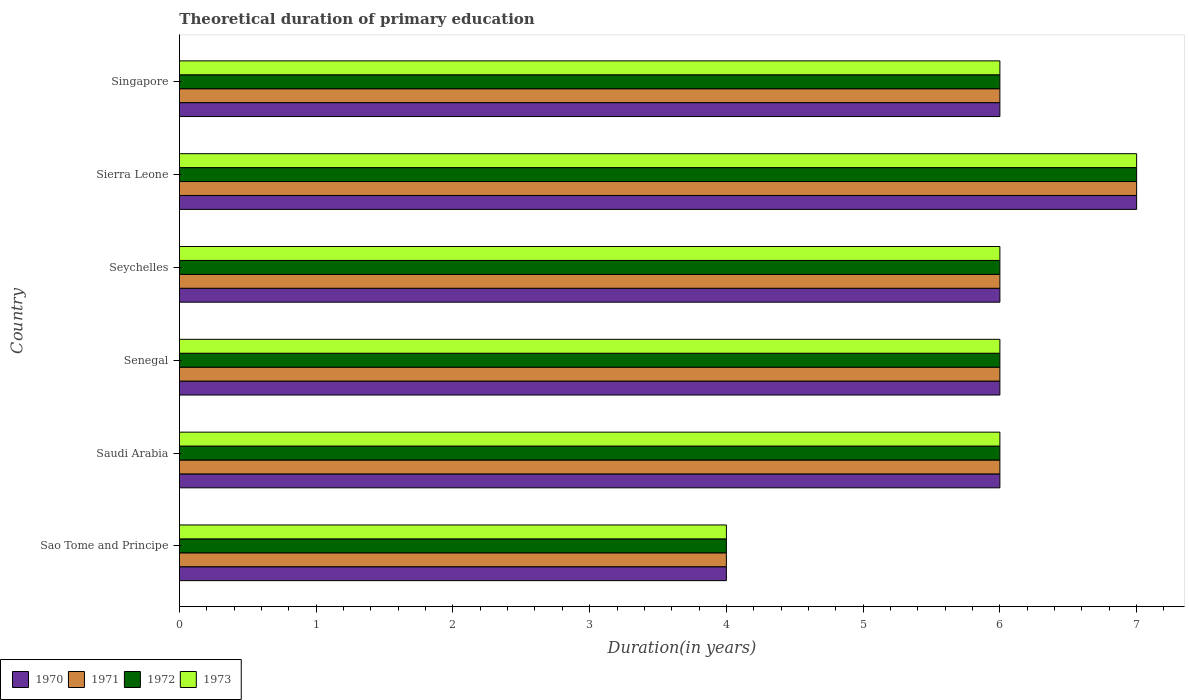How many groups of bars are there?
Offer a very short reply. 6. Are the number of bars per tick equal to the number of legend labels?
Your answer should be very brief. Yes. How many bars are there on the 4th tick from the top?
Ensure brevity in your answer.  4. What is the label of the 3rd group of bars from the top?
Your answer should be compact. Seychelles. In how many cases, is the number of bars for a given country not equal to the number of legend labels?
Your answer should be compact. 0. What is the total theoretical duration of primary education in 1970 in Saudi Arabia?
Ensure brevity in your answer.  6. In which country was the total theoretical duration of primary education in 1973 maximum?
Provide a succinct answer. Sierra Leone. In which country was the total theoretical duration of primary education in 1973 minimum?
Your answer should be very brief. Sao Tome and Principe. What is the total total theoretical duration of primary education in 1970 in the graph?
Offer a terse response. 35. What is the average total theoretical duration of primary education in 1973 per country?
Your response must be concise. 5.83. In how many countries, is the total theoretical duration of primary education in 1971 greater than 6.2 years?
Make the answer very short. 1. What is the ratio of the total theoretical duration of primary education in 1973 in Saudi Arabia to that in Senegal?
Give a very brief answer. 1. Is the total theoretical duration of primary education in 1972 in Saudi Arabia less than that in Senegal?
Make the answer very short. No. What is the difference between the highest and the second highest total theoretical duration of primary education in 1971?
Your answer should be compact. 1. In how many countries, is the total theoretical duration of primary education in 1973 greater than the average total theoretical duration of primary education in 1973 taken over all countries?
Offer a terse response. 5. Is the sum of the total theoretical duration of primary education in 1972 in Sierra Leone and Singapore greater than the maximum total theoretical duration of primary education in 1970 across all countries?
Your answer should be very brief. Yes. What does the 3rd bar from the top in Seychelles represents?
Ensure brevity in your answer.  1971. Is it the case that in every country, the sum of the total theoretical duration of primary education in 1973 and total theoretical duration of primary education in 1970 is greater than the total theoretical duration of primary education in 1971?
Offer a very short reply. Yes. Are all the bars in the graph horizontal?
Offer a terse response. Yes. Are the values on the major ticks of X-axis written in scientific E-notation?
Your answer should be compact. No. Does the graph contain any zero values?
Provide a succinct answer. No. Where does the legend appear in the graph?
Your response must be concise. Bottom left. How many legend labels are there?
Ensure brevity in your answer.  4. What is the title of the graph?
Your answer should be compact. Theoretical duration of primary education. Does "1969" appear as one of the legend labels in the graph?
Ensure brevity in your answer.  No. What is the label or title of the X-axis?
Make the answer very short. Duration(in years). What is the label or title of the Y-axis?
Give a very brief answer. Country. What is the Duration(in years) in 1970 in Sao Tome and Principe?
Your answer should be very brief. 4. What is the Duration(in years) of 1973 in Sao Tome and Principe?
Provide a succinct answer. 4. What is the Duration(in years) of 1971 in Saudi Arabia?
Keep it short and to the point. 6. What is the Duration(in years) of 1972 in Saudi Arabia?
Provide a succinct answer. 6. What is the Duration(in years) in 1973 in Saudi Arabia?
Your answer should be very brief. 6. What is the Duration(in years) in 1971 in Senegal?
Your answer should be compact. 6. What is the Duration(in years) of 1973 in Senegal?
Make the answer very short. 6. What is the Duration(in years) in 1970 in Sierra Leone?
Your response must be concise. 7. What is the Duration(in years) of 1971 in Sierra Leone?
Your answer should be very brief. 7. What is the Duration(in years) in 1972 in Sierra Leone?
Provide a short and direct response. 7. What is the Duration(in years) in 1970 in Singapore?
Your answer should be very brief. 6. What is the Duration(in years) of 1971 in Singapore?
Give a very brief answer. 6. What is the Duration(in years) of 1972 in Singapore?
Your answer should be compact. 6. Across all countries, what is the maximum Duration(in years) in 1971?
Ensure brevity in your answer.  7. Across all countries, what is the minimum Duration(in years) of 1970?
Your answer should be compact. 4. Across all countries, what is the minimum Duration(in years) in 1972?
Make the answer very short. 4. Across all countries, what is the minimum Duration(in years) of 1973?
Your answer should be compact. 4. What is the total Duration(in years) in 1972 in the graph?
Provide a short and direct response. 35. What is the total Duration(in years) in 1973 in the graph?
Your answer should be very brief. 35. What is the difference between the Duration(in years) in 1970 in Sao Tome and Principe and that in Saudi Arabia?
Provide a succinct answer. -2. What is the difference between the Duration(in years) in 1971 in Sao Tome and Principe and that in Saudi Arabia?
Ensure brevity in your answer.  -2. What is the difference between the Duration(in years) in 1972 in Sao Tome and Principe and that in Saudi Arabia?
Keep it short and to the point. -2. What is the difference between the Duration(in years) in 1973 in Sao Tome and Principe and that in Saudi Arabia?
Provide a short and direct response. -2. What is the difference between the Duration(in years) of 1971 in Sao Tome and Principe and that in Senegal?
Provide a succinct answer. -2. What is the difference between the Duration(in years) in 1972 in Sao Tome and Principe and that in Senegal?
Provide a short and direct response. -2. What is the difference between the Duration(in years) of 1973 in Sao Tome and Principe and that in Senegal?
Your answer should be compact. -2. What is the difference between the Duration(in years) in 1973 in Sao Tome and Principe and that in Seychelles?
Give a very brief answer. -2. What is the difference between the Duration(in years) of 1970 in Sao Tome and Principe and that in Sierra Leone?
Make the answer very short. -3. What is the difference between the Duration(in years) in 1972 in Sao Tome and Principe and that in Sierra Leone?
Ensure brevity in your answer.  -3. What is the difference between the Duration(in years) of 1973 in Sao Tome and Principe and that in Sierra Leone?
Ensure brevity in your answer.  -3. What is the difference between the Duration(in years) in 1972 in Sao Tome and Principe and that in Singapore?
Your answer should be very brief. -2. What is the difference between the Duration(in years) of 1973 in Sao Tome and Principe and that in Singapore?
Offer a terse response. -2. What is the difference between the Duration(in years) in 1971 in Saudi Arabia and that in Senegal?
Your answer should be compact. 0. What is the difference between the Duration(in years) in 1973 in Saudi Arabia and that in Senegal?
Your answer should be very brief. 0. What is the difference between the Duration(in years) in 1970 in Saudi Arabia and that in Seychelles?
Offer a very short reply. 0. What is the difference between the Duration(in years) of 1970 in Saudi Arabia and that in Sierra Leone?
Keep it short and to the point. -1. What is the difference between the Duration(in years) in 1971 in Saudi Arabia and that in Sierra Leone?
Offer a very short reply. -1. What is the difference between the Duration(in years) in 1973 in Saudi Arabia and that in Sierra Leone?
Provide a succinct answer. -1. What is the difference between the Duration(in years) of 1973 in Saudi Arabia and that in Singapore?
Your response must be concise. 0. What is the difference between the Duration(in years) in 1970 in Senegal and that in Seychelles?
Make the answer very short. 0. What is the difference between the Duration(in years) of 1971 in Senegal and that in Sierra Leone?
Your response must be concise. -1. What is the difference between the Duration(in years) in 1972 in Senegal and that in Sierra Leone?
Your response must be concise. -1. What is the difference between the Duration(in years) in 1972 in Seychelles and that in Sierra Leone?
Your response must be concise. -1. What is the difference between the Duration(in years) of 1970 in Seychelles and that in Singapore?
Your answer should be compact. 0. What is the difference between the Duration(in years) in 1971 in Seychelles and that in Singapore?
Give a very brief answer. 0. What is the difference between the Duration(in years) in 1970 in Sao Tome and Principe and the Duration(in years) in 1971 in Saudi Arabia?
Ensure brevity in your answer.  -2. What is the difference between the Duration(in years) in 1970 in Sao Tome and Principe and the Duration(in years) in 1972 in Saudi Arabia?
Offer a terse response. -2. What is the difference between the Duration(in years) in 1970 in Sao Tome and Principe and the Duration(in years) in 1973 in Saudi Arabia?
Your answer should be compact. -2. What is the difference between the Duration(in years) of 1971 in Sao Tome and Principe and the Duration(in years) of 1972 in Saudi Arabia?
Give a very brief answer. -2. What is the difference between the Duration(in years) of 1970 in Sao Tome and Principe and the Duration(in years) of 1971 in Senegal?
Keep it short and to the point. -2. What is the difference between the Duration(in years) of 1970 in Sao Tome and Principe and the Duration(in years) of 1972 in Senegal?
Offer a terse response. -2. What is the difference between the Duration(in years) of 1972 in Sao Tome and Principe and the Duration(in years) of 1973 in Senegal?
Give a very brief answer. -2. What is the difference between the Duration(in years) in 1970 in Sao Tome and Principe and the Duration(in years) in 1972 in Seychelles?
Provide a succinct answer. -2. What is the difference between the Duration(in years) of 1970 in Sao Tome and Principe and the Duration(in years) of 1973 in Seychelles?
Keep it short and to the point. -2. What is the difference between the Duration(in years) of 1971 in Sao Tome and Principe and the Duration(in years) of 1973 in Seychelles?
Give a very brief answer. -2. What is the difference between the Duration(in years) of 1972 in Sao Tome and Principe and the Duration(in years) of 1973 in Seychelles?
Your response must be concise. -2. What is the difference between the Duration(in years) in 1970 in Sao Tome and Principe and the Duration(in years) in 1973 in Sierra Leone?
Your answer should be compact. -3. What is the difference between the Duration(in years) of 1971 in Sao Tome and Principe and the Duration(in years) of 1973 in Sierra Leone?
Keep it short and to the point. -3. What is the difference between the Duration(in years) in 1972 in Sao Tome and Principe and the Duration(in years) in 1973 in Sierra Leone?
Your answer should be compact. -3. What is the difference between the Duration(in years) of 1970 in Sao Tome and Principe and the Duration(in years) of 1973 in Singapore?
Offer a very short reply. -2. What is the difference between the Duration(in years) of 1971 in Sao Tome and Principe and the Duration(in years) of 1972 in Singapore?
Your answer should be compact. -2. What is the difference between the Duration(in years) of 1970 in Saudi Arabia and the Duration(in years) of 1972 in Senegal?
Provide a succinct answer. 0. What is the difference between the Duration(in years) in 1970 in Saudi Arabia and the Duration(in years) in 1973 in Senegal?
Provide a succinct answer. 0. What is the difference between the Duration(in years) in 1970 in Saudi Arabia and the Duration(in years) in 1972 in Seychelles?
Ensure brevity in your answer.  0. What is the difference between the Duration(in years) of 1971 in Saudi Arabia and the Duration(in years) of 1973 in Seychelles?
Your answer should be very brief. 0. What is the difference between the Duration(in years) in 1971 in Saudi Arabia and the Duration(in years) in 1972 in Sierra Leone?
Your answer should be very brief. -1. What is the difference between the Duration(in years) of 1971 in Saudi Arabia and the Duration(in years) of 1973 in Sierra Leone?
Offer a terse response. -1. What is the difference between the Duration(in years) in 1972 in Saudi Arabia and the Duration(in years) in 1973 in Sierra Leone?
Your answer should be compact. -1. What is the difference between the Duration(in years) of 1970 in Saudi Arabia and the Duration(in years) of 1972 in Singapore?
Provide a succinct answer. 0. What is the difference between the Duration(in years) in 1970 in Saudi Arabia and the Duration(in years) in 1973 in Singapore?
Your response must be concise. 0. What is the difference between the Duration(in years) of 1971 in Saudi Arabia and the Duration(in years) of 1972 in Singapore?
Your answer should be compact. 0. What is the difference between the Duration(in years) of 1970 in Senegal and the Duration(in years) of 1972 in Seychelles?
Provide a short and direct response. 0. What is the difference between the Duration(in years) in 1971 in Senegal and the Duration(in years) in 1972 in Seychelles?
Offer a terse response. 0. What is the difference between the Duration(in years) in 1971 in Senegal and the Duration(in years) in 1973 in Seychelles?
Give a very brief answer. 0. What is the difference between the Duration(in years) of 1970 in Senegal and the Duration(in years) of 1972 in Sierra Leone?
Keep it short and to the point. -1. What is the difference between the Duration(in years) in 1971 in Senegal and the Duration(in years) in 1972 in Sierra Leone?
Give a very brief answer. -1. What is the difference between the Duration(in years) of 1971 in Senegal and the Duration(in years) of 1973 in Sierra Leone?
Offer a very short reply. -1. What is the difference between the Duration(in years) in 1970 in Senegal and the Duration(in years) in 1971 in Singapore?
Ensure brevity in your answer.  0. What is the difference between the Duration(in years) of 1972 in Senegal and the Duration(in years) of 1973 in Singapore?
Your answer should be compact. 0. What is the difference between the Duration(in years) of 1970 in Seychelles and the Duration(in years) of 1971 in Sierra Leone?
Ensure brevity in your answer.  -1. What is the difference between the Duration(in years) in 1971 in Seychelles and the Duration(in years) in 1972 in Sierra Leone?
Your answer should be compact. -1. What is the difference between the Duration(in years) in 1970 in Seychelles and the Duration(in years) in 1971 in Singapore?
Offer a very short reply. 0. What is the difference between the Duration(in years) of 1970 in Seychelles and the Duration(in years) of 1973 in Singapore?
Provide a succinct answer. 0. What is the difference between the Duration(in years) of 1971 in Seychelles and the Duration(in years) of 1972 in Singapore?
Ensure brevity in your answer.  0. What is the difference between the Duration(in years) of 1971 in Seychelles and the Duration(in years) of 1973 in Singapore?
Offer a terse response. 0. What is the difference between the Duration(in years) of 1972 in Seychelles and the Duration(in years) of 1973 in Singapore?
Offer a terse response. 0. What is the difference between the Duration(in years) of 1970 in Sierra Leone and the Duration(in years) of 1972 in Singapore?
Your answer should be compact. 1. What is the difference between the Duration(in years) in 1972 in Sierra Leone and the Duration(in years) in 1973 in Singapore?
Your response must be concise. 1. What is the average Duration(in years) in 1970 per country?
Ensure brevity in your answer.  5.83. What is the average Duration(in years) in 1971 per country?
Provide a succinct answer. 5.83. What is the average Duration(in years) of 1972 per country?
Ensure brevity in your answer.  5.83. What is the average Duration(in years) of 1973 per country?
Your answer should be compact. 5.83. What is the difference between the Duration(in years) in 1970 and Duration(in years) in 1971 in Sao Tome and Principe?
Offer a terse response. 0. What is the difference between the Duration(in years) in 1970 and Duration(in years) in 1973 in Sao Tome and Principe?
Your answer should be compact. 0. What is the difference between the Duration(in years) of 1971 and Duration(in years) of 1972 in Sao Tome and Principe?
Provide a succinct answer. 0. What is the difference between the Duration(in years) of 1972 and Duration(in years) of 1973 in Sao Tome and Principe?
Keep it short and to the point. 0. What is the difference between the Duration(in years) of 1970 and Duration(in years) of 1971 in Saudi Arabia?
Your answer should be very brief. 0. What is the difference between the Duration(in years) of 1970 and Duration(in years) of 1972 in Saudi Arabia?
Your response must be concise. 0. What is the difference between the Duration(in years) in 1971 and Duration(in years) in 1972 in Saudi Arabia?
Provide a short and direct response. 0. What is the difference between the Duration(in years) of 1972 and Duration(in years) of 1973 in Saudi Arabia?
Your answer should be very brief. 0. What is the difference between the Duration(in years) in 1972 and Duration(in years) in 1973 in Senegal?
Give a very brief answer. 0. What is the difference between the Duration(in years) of 1971 and Duration(in years) of 1972 in Seychelles?
Make the answer very short. 0. What is the difference between the Duration(in years) in 1971 and Duration(in years) in 1973 in Seychelles?
Make the answer very short. 0. What is the difference between the Duration(in years) in 1972 and Duration(in years) in 1973 in Seychelles?
Make the answer very short. 0. What is the difference between the Duration(in years) in 1971 and Duration(in years) in 1972 in Sierra Leone?
Give a very brief answer. 0. What is the difference between the Duration(in years) in 1971 and Duration(in years) in 1972 in Singapore?
Offer a very short reply. 0. What is the difference between the Duration(in years) of 1972 and Duration(in years) of 1973 in Singapore?
Offer a very short reply. 0. What is the ratio of the Duration(in years) in 1971 in Sao Tome and Principe to that in Saudi Arabia?
Your answer should be compact. 0.67. What is the ratio of the Duration(in years) in 1972 in Sao Tome and Principe to that in Saudi Arabia?
Your answer should be very brief. 0.67. What is the ratio of the Duration(in years) of 1973 in Sao Tome and Principe to that in Saudi Arabia?
Keep it short and to the point. 0.67. What is the ratio of the Duration(in years) of 1971 in Sao Tome and Principe to that in Senegal?
Give a very brief answer. 0.67. What is the ratio of the Duration(in years) in 1972 in Sao Tome and Principe to that in Senegal?
Offer a terse response. 0.67. What is the ratio of the Duration(in years) in 1973 in Sao Tome and Principe to that in Seychelles?
Keep it short and to the point. 0.67. What is the ratio of the Duration(in years) in 1970 in Sao Tome and Principe to that in Sierra Leone?
Your response must be concise. 0.57. What is the ratio of the Duration(in years) in 1972 in Sao Tome and Principe to that in Sierra Leone?
Keep it short and to the point. 0.57. What is the ratio of the Duration(in years) in 1973 in Sao Tome and Principe to that in Sierra Leone?
Make the answer very short. 0.57. What is the ratio of the Duration(in years) in 1970 in Sao Tome and Principe to that in Singapore?
Your response must be concise. 0.67. What is the ratio of the Duration(in years) of 1973 in Sao Tome and Principe to that in Singapore?
Make the answer very short. 0.67. What is the ratio of the Duration(in years) in 1971 in Saudi Arabia to that in Senegal?
Offer a very short reply. 1. What is the ratio of the Duration(in years) in 1970 in Saudi Arabia to that in Seychelles?
Keep it short and to the point. 1. What is the ratio of the Duration(in years) in 1970 in Saudi Arabia to that in Sierra Leone?
Keep it short and to the point. 0.86. What is the ratio of the Duration(in years) in 1971 in Saudi Arabia to that in Sierra Leone?
Provide a short and direct response. 0.86. What is the ratio of the Duration(in years) of 1972 in Saudi Arabia to that in Sierra Leone?
Your response must be concise. 0.86. What is the ratio of the Duration(in years) in 1970 in Saudi Arabia to that in Singapore?
Make the answer very short. 1. What is the ratio of the Duration(in years) of 1971 in Saudi Arabia to that in Singapore?
Your response must be concise. 1. What is the ratio of the Duration(in years) of 1973 in Senegal to that in Seychelles?
Offer a terse response. 1. What is the ratio of the Duration(in years) of 1970 in Senegal to that in Sierra Leone?
Your answer should be compact. 0.86. What is the ratio of the Duration(in years) of 1973 in Senegal to that in Sierra Leone?
Provide a short and direct response. 0.86. What is the ratio of the Duration(in years) of 1970 in Senegal to that in Singapore?
Your response must be concise. 1. What is the ratio of the Duration(in years) of 1971 in Senegal to that in Singapore?
Your answer should be compact. 1. What is the ratio of the Duration(in years) in 1971 in Seychelles to that in Sierra Leone?
Offer a terse response. 0.86. What is the ratio of the Duration(in years) of 1972 in Seychelles to that in Sierra Leone?
Keep it short and to the point. 0.86. What is the ratio of the Duration(in years) of 1973 in Seychelles to that in Sierra Leone?
Your answer should be compact. 0.86. What is the ratio of the Duration(in years) of 1971 in Seychelles to that in Singapore?
Give a very brief answer. 1. What is the ratio of the Duration(in years) in 1972 in Seychelles to that in Singapore?
Provide a short and direct response. 1. What is the ratio of the Duration(in years) of 1973 in Seychelles to that in Singapore?
Provide a succinct answer. 1. What is the ratio of the Duration(in years) of 1971 in Sierra Leone to that in Singapore?
Ensure brevity in your answer.  1.17. What is the ratio of the Duration(in years) of 1972 in Sierra Leone to that in Singapore?
Your response must be concise. 1.17. What is the ratio of the Duration(in years) in 1973 in Sierra Leone to that in Singapore?
Provide a succinct answer. 1.17. What is the difference between the highest and the second highest Duration(in years) in 1970?
Your answer should be very brief. 1. What is the difference between the highest and the second highest Duration(in years) in 1971?
Give a very brief answer. 1. What is the difference between the highest and the second highest Duration(in years) of 1972?
Your response must be concise. 1. What is the difference between the highest and the second highest Duration(in years) in 1973?
Offer a very short reply. 1. What is the difference between the highest and the lowest Duration(in years) in 1971?
Offer a very short reply. 3. What is the difference between the highest and the lowest Duration(in years) of 1972?
Provide a succinct answer. 3. 